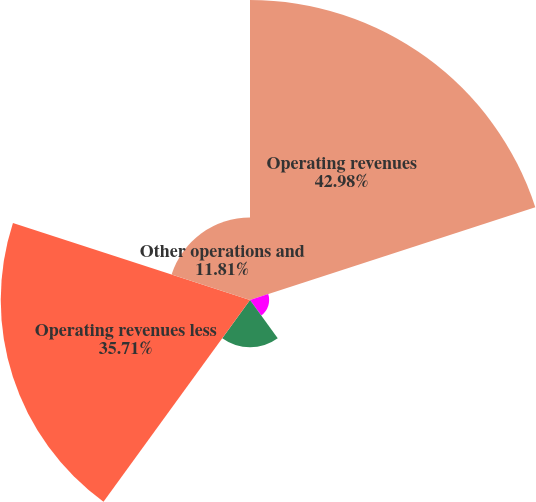Convert chart. <chart><loc_0><loc_0><loc_500><loc_500><pie_chart><fcel>Operating revenues<fcel>Purchased power<fcel>Gas purchased for resale<fcel>Operating revenues less<fcel>Other operations and<nl><fcel>42.98%<fcel>2.74%<fcel>6.76%<fcel>35.71%<fcel>11.81%<nl></chart> 